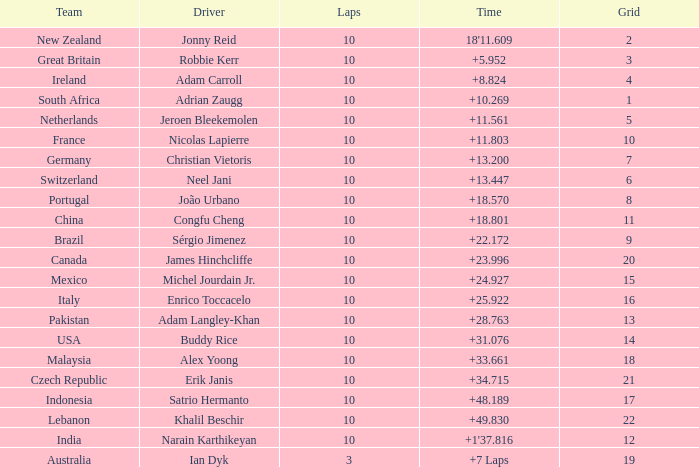Can you provide the grid number for italy's team? 1.0. 